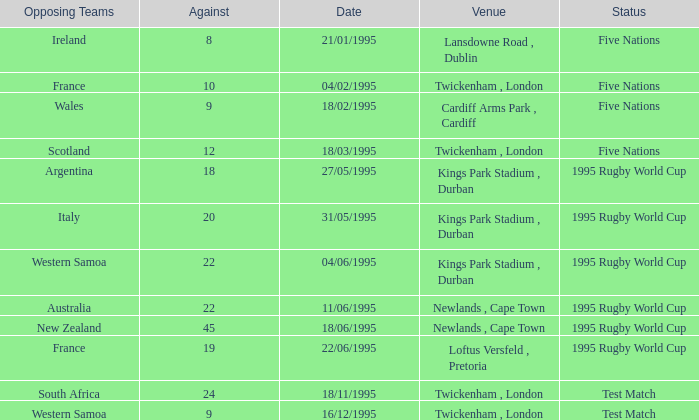What is the situation regarding an against over 20 on november 18, 1995? Test Match. 